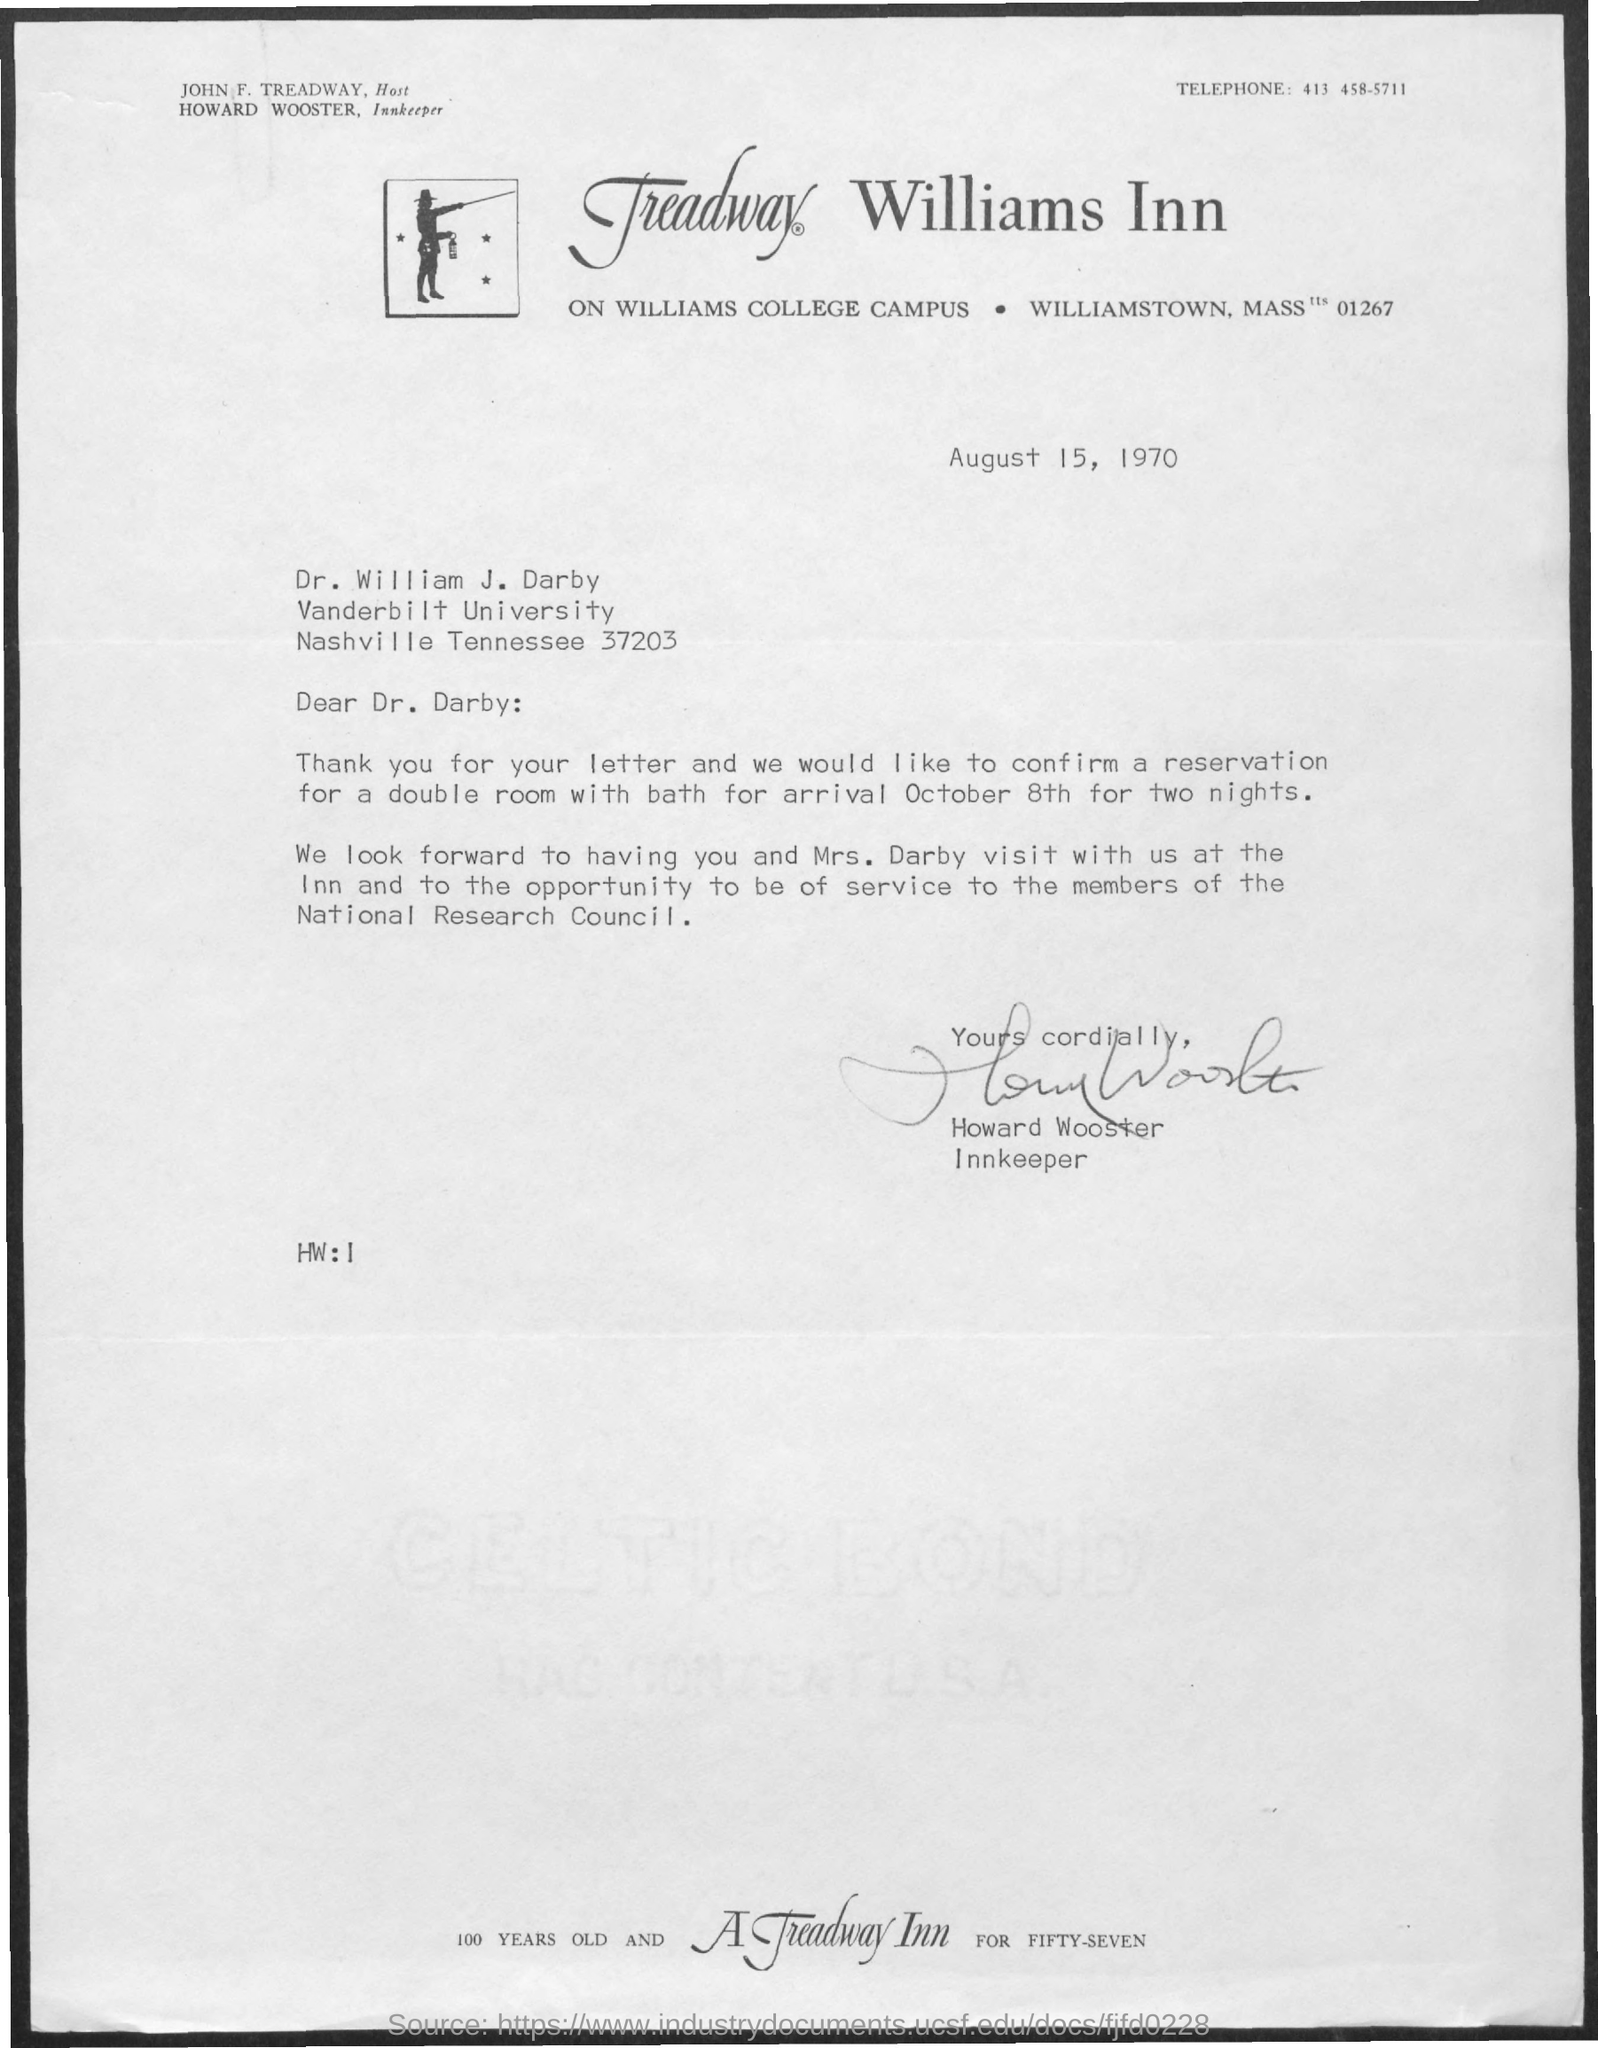List a handful of essential elements in this visual. The memorandum is from Howard Wooster. The memorandum is dated August 15, 1970. The telephone number is 413 458-5711. 